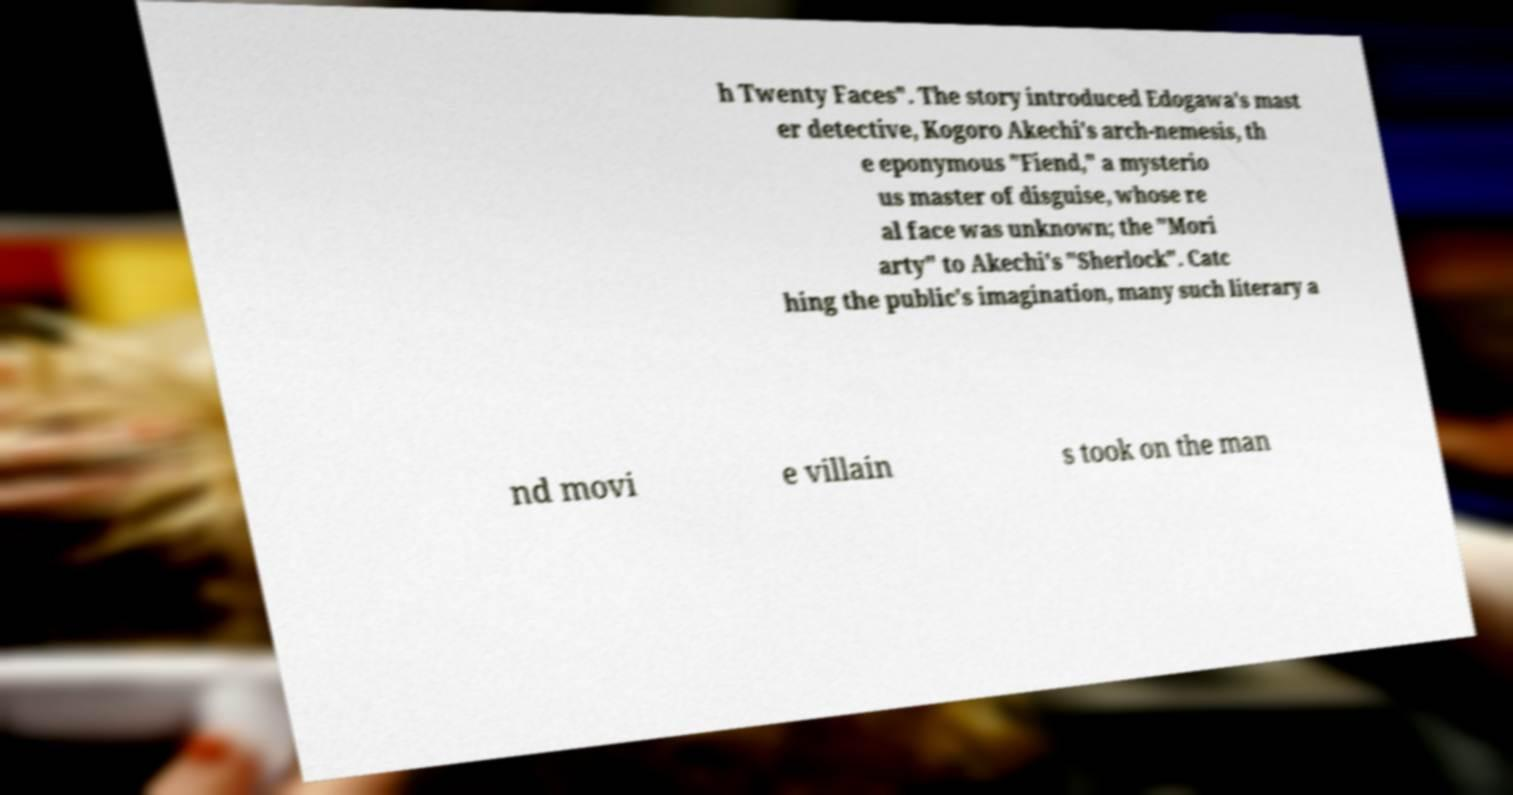For documentation purposes, I need the text within this image transcribed. Could you provide that? h Twenty Faces". The story introduced Edogawa's mast er detective, Kogoro Akechi's arch-nemesis, th e eponymous "Fiend," a mysterio us master of disguise, whose re al face was unknown; the "Mori arty" to Akechi's "Sherlock". Catc hing the public's imagination, many such literary a nd movi e villain s took on the man 